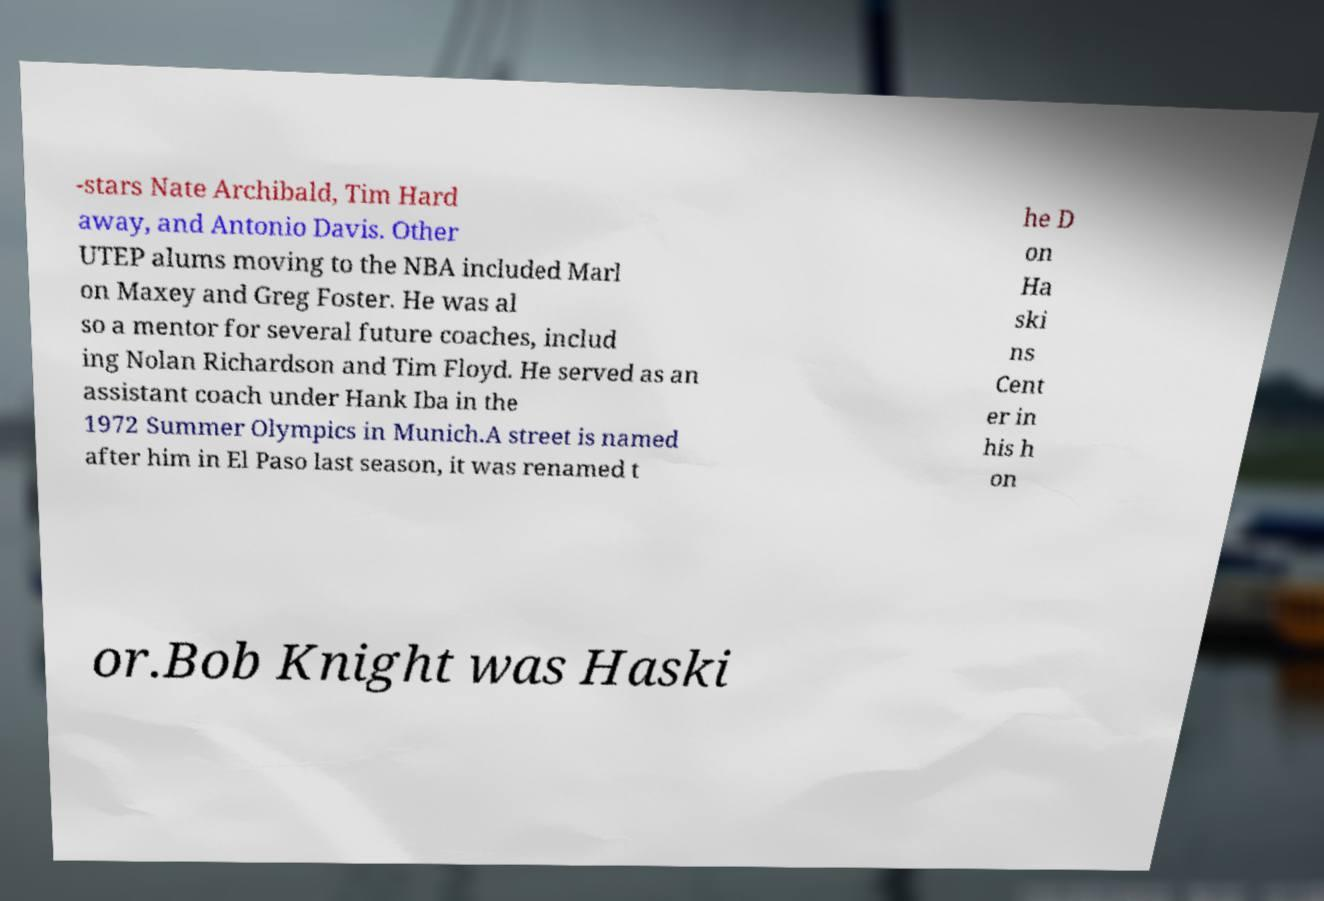Please read and relay the text visible in this image. What does it say? -stars Nate Archibald, Tim Hard away, and Antonio Davis. Other UTEP alums moving to the NBA included Marl on Maxey and Greg Foster. He was al so a mentor for several future coaches, includ ing Nolan Richardson and Tim Floyd. He served as an assistant coach under Hank Iba in the 1972 Summer Olympics in Munich.A street is named after him in El Paso last season, it was renamed t he D on Ha ski ns Cent er in his h on or.Bob Knight was Haski 